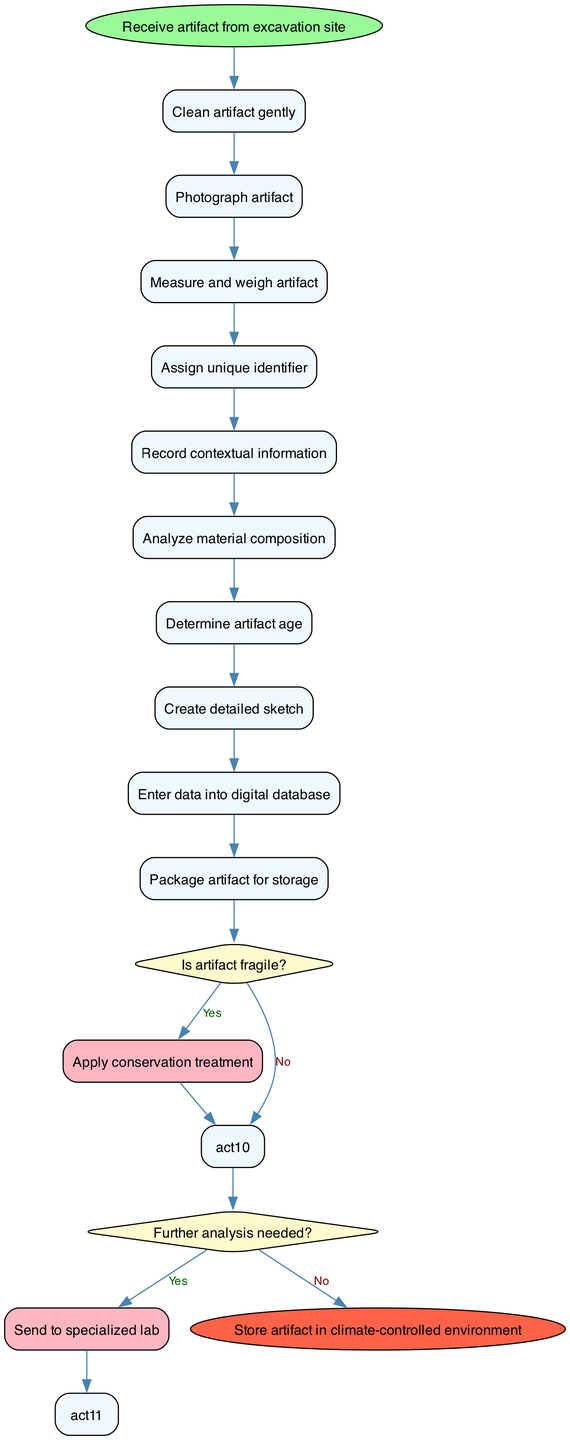What is the starting node in the diagram? The starting node in the diagram is labeled "Receive artifact from excavation site," indicating the initial action in the workflow.
Answer: Receive artifact from excavation site How many activities are there in total? The total number of activities listed in the diagram is ten, each representing a distinct step in the artifact preservation process.
Answer: 10 What happens if the artifact is not fragile? If the artifact is not fragile, the workflow proceeds to the next step after measuring, weighing, and photographing it, indicating a smooth continuation of the process.
Answer: Proceed to next step What is the last activity before determining the need for further analysis? The last activity before determining if further analysis is needed is to "Analyze material composition," where the characteristics of the artifact are assessed.
Answer: Analyze material composition What is the final step in the workflow? The final step in the workflow is to "Store artifact in climate-controlled environment," which ensures proper preservation after all activities are completed.
Answer: Store artifact in climate-controlled environment If the artifact requires conservation treatment, what is the next step after that? If conservation treatment is required, the workflow progresses to "Prepare for storage" after addressing the fragility of the artifact, ensuring it is adequately preserved.
Answer: Prepare for storage How many decisions are present in the diagram? There are two decisions in the diagram, each leading to different paths based on whether the artifact is fragile or if further analysis is needed.
Answer: 2 What do you do if further analysis is needed? If further analysis is needed, the next step is to send the artifact to a specialized lab for additional examination, emphasizing the importance of thorough examination when necessary.
Answer: Send to specialized lab 